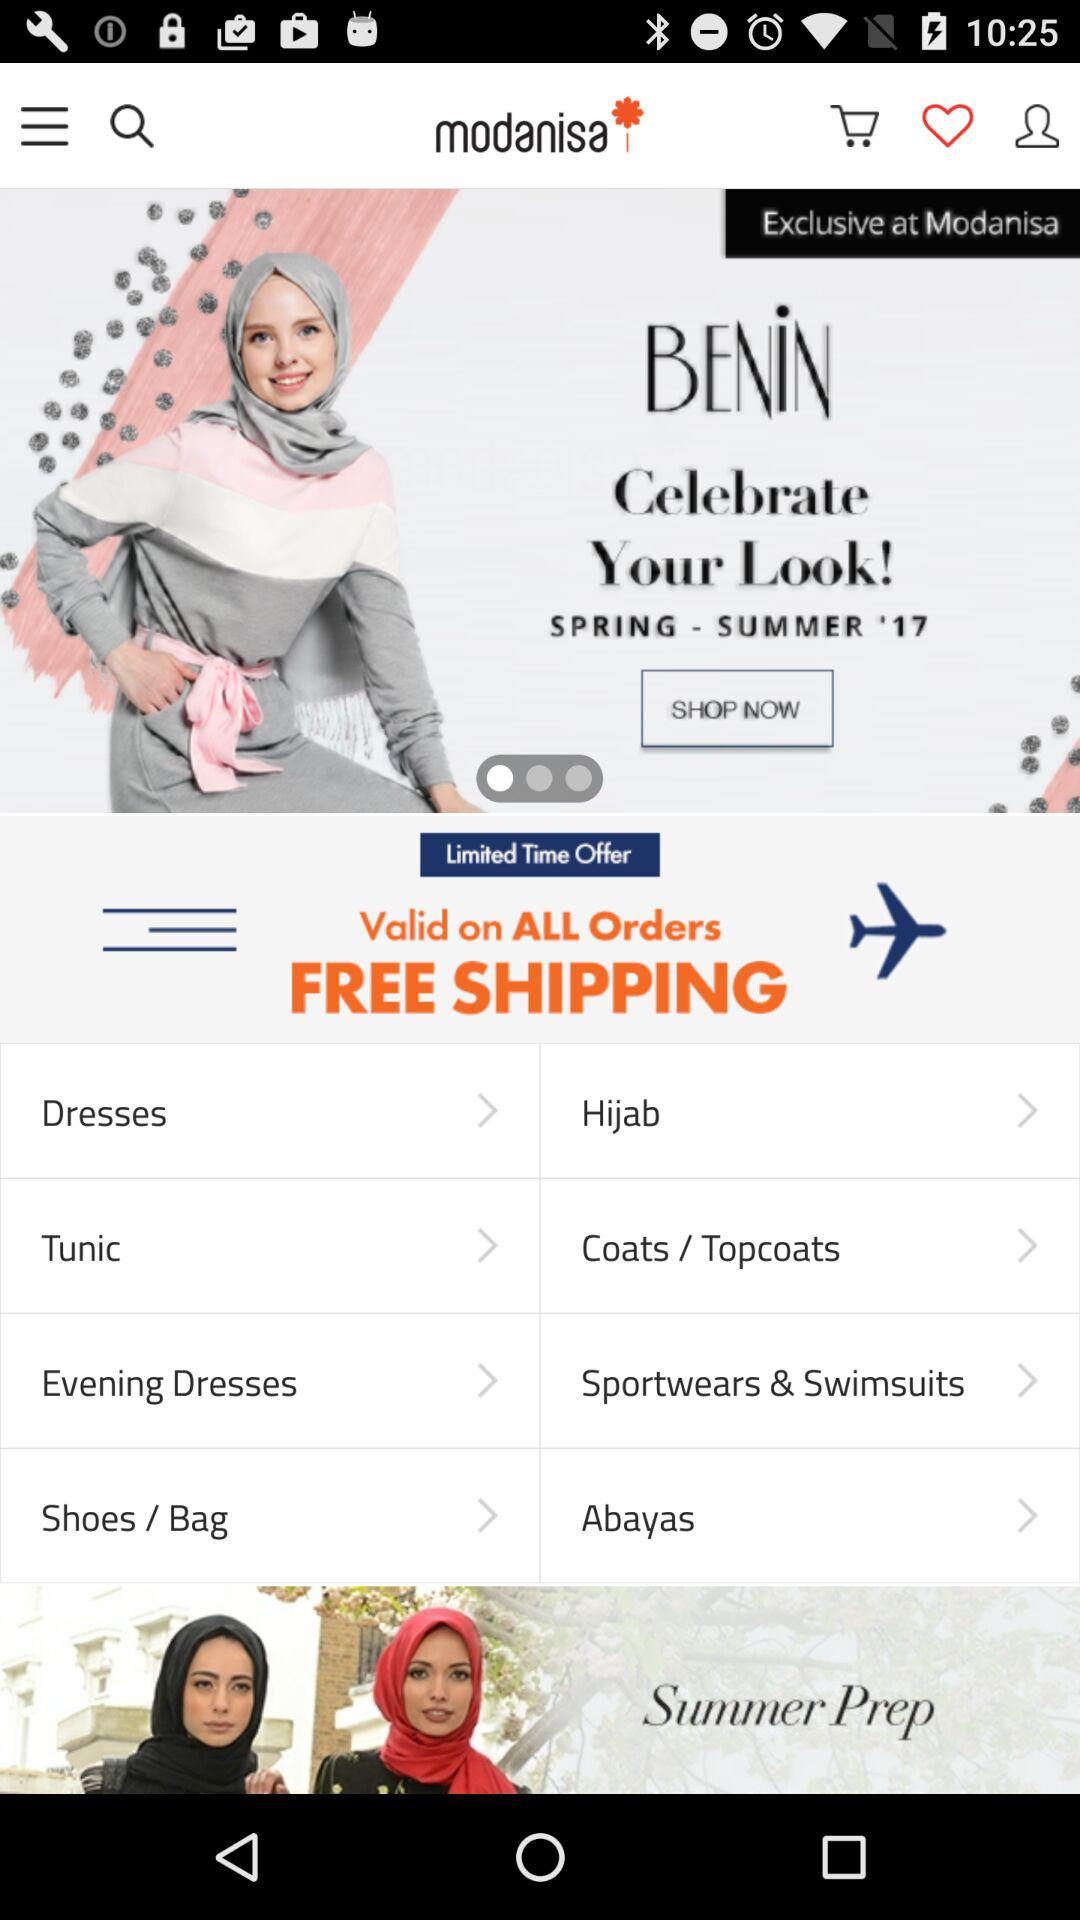What are the shipping charges? The shipping is free. 